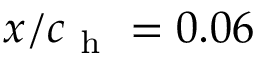Convert formula to latex. <formula><loc_0><loc_0><loc_500><loc_500>x / c _ { h } = 0 . 0 6</formula> 